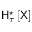Convert formula to latex. <formula><loc_0><loc_0><loc_500><loc_500>H _ { \tau } ^ { ^ { * } } \left [ X \right ]</formula> 